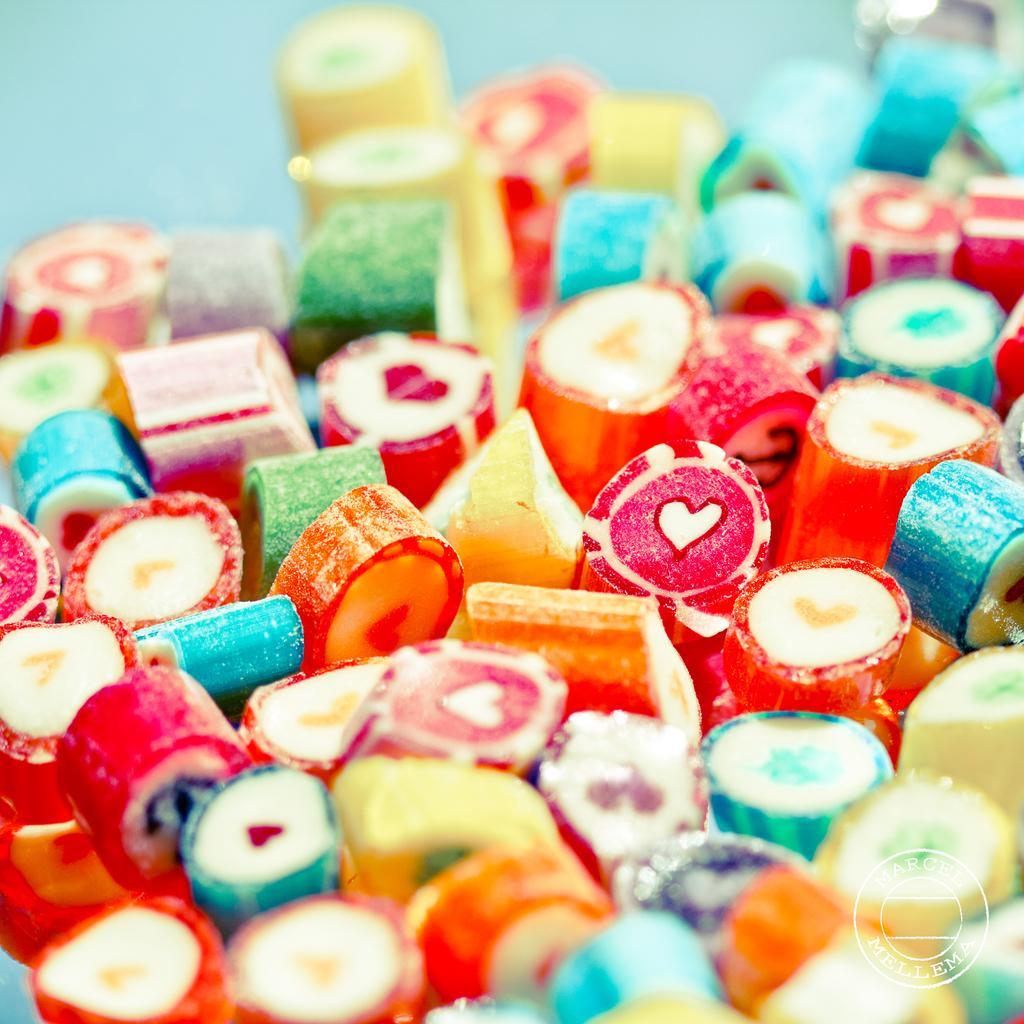Could you give a brief overview of what you see in this image? In the image we can see there are many candies of different color. 